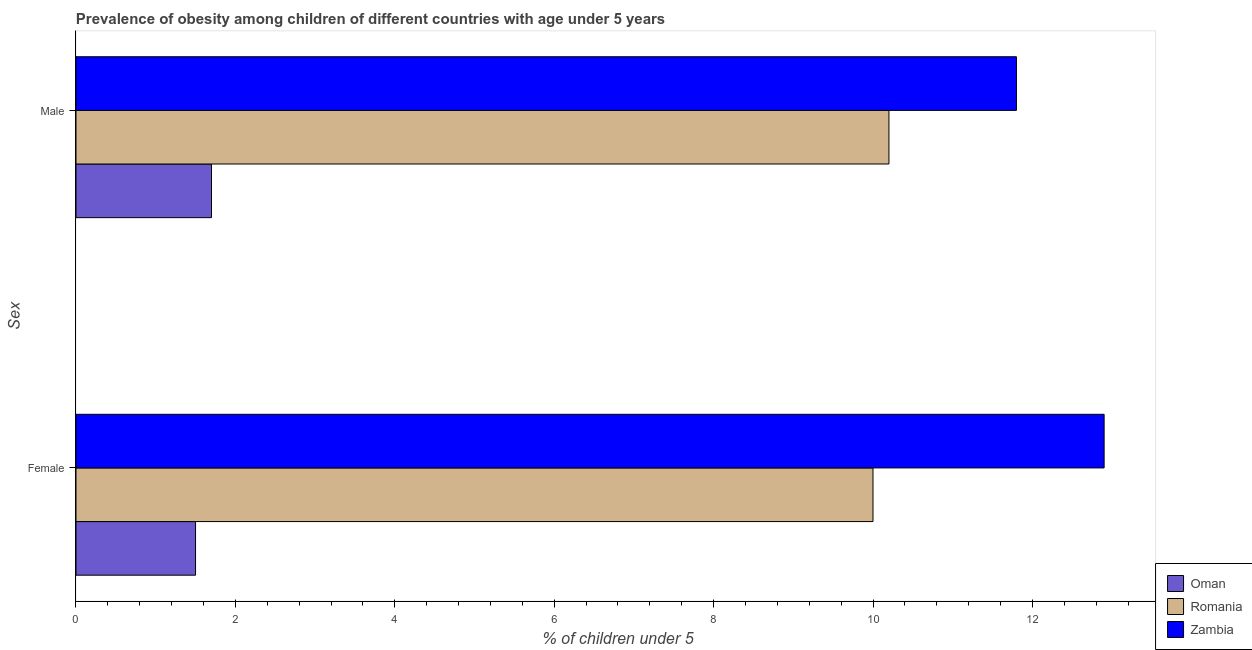How many different coloured bars are there?
Ensure brevity in your answer.  3. How many groups of bars are there?
Offer a very short reply. 2. Are the number of bars per tick equal to the number of legend labels?
Provide a short and direct response. Yes. Are the number of bars on each tick of the Y-axis equal?
Your answer should be very brief. Yes. How many bars are there on the 1st tick from the bottom?
Provide a short and direct response. 3. What is the percentage of obese female children in Romania?
Offer a terse response. 10. Across all countries, what is the maximum percentage of obese male children?
Keep it short and to the point. 11.8. Across all countries, what is the minimum percentage of obese female children?
Offer a terse response. 1.5. In which country was the percentage of obese male children maximum?
Ensure brevity in your answer.  Zambia. In which country was the percentage of obese male children minimum?
Your answer should be very brief. Oman. What is the total percentage of obese female children in the graph?
Offer a terse response. 24.4. What is the difference between the percentage of obese male children in Romania and that in Oman?
Your answer should be very brief. 8.5. What is the difference between the percentage of obese male children in Zambia and the percentage of obese female children in Oman?
Your response must be concise. 10.3. What is the average percentage of obese female children per country?
Make the answer very short. 8.13. What is the difference between the percentage of obese male children and percentage of obese female children in Zambia?
Provide a short and direct response. -1.1. In how many countries, is the percentage of obese female children greater than 10.4 %?
Your answer should be compact. 1. What is the ratio of the percentage of obese female children in Zambia to that in Oman?
Make the answer very short. 8.6. In how many countries, is the percentage of obese male children greater than the average percentage of obese male children taken over all countries?
Offer a very short reply. 2. What does the 3rd bar from the top in Female represents?
Your response must be concise. Oman. What does the 2nd bar from the bottom in Female represents?
Provide a succinct answer. Romania. Are the values on the major ticks of X-axis written in scientific E-notation?
Ensure brevity in your answer.  No. Where does the legend appear in the graph?
Your answer should be compact. Bottom right. What is the title of the graph?
Your answer should be compact. Prevalence of obesity among children of different countries with age under 5 years. Does "Suriname" appear as one of the legend labels in the graph?
Ensure brevity in your answer.  No. What is the label or title of the X-axis?
Offer a terse response.  % of children under 5. What is the label or title of the Y-axis?
Offer a very short reply. Sex. What is the  % of children under 5 in Oman in Female?
Your response must be concise. 1.5. What is the  % of children under 5 of Romania in Female?
Your answer should be very brief. 10. What is the  % of children under 5 in Zambia in Female?
Offer a terse response. 12.9. What is the  % of children under 5 in Oman in Male?
Provide a short and direct response. 1.7. What is the  % of children under 5 in Romania in Male?
Ensure brevity in your answer.  10.2. What is the  % of children under 5 of Zambia in Male?
Provide a short and direct response. 11.8. Across all Sex, what is the maximum  % of children under 5 of Oman?
Your answer should be very brief. 1.7. Across all Sex, what is the maximum  % of children under 5 in Romania?
Your answer should be very brief. 10.2. Across all Sex, what is the maximum  % of children under 5 of Zambia?
Ensure brevity in your answer.  12.9. Across all Sex, what is the minimum  % of children under 5 of Zambia?
Your answer should be very brief. 11.8. What is the total  % of children under 5 in Oman in the graph?
Your response must be concise. 3.2. What is the total  % of children under 5 of Romania in the graph?
Your answer should be very brief. 20.2. What is the total  % of children under 5 in Zambia in the graph?
Your answer should be very brief. 24.7. What is the difference between the  % of children under 5 in Zambia in Female and that in Male?
Provide a succinct answer. 1.1. What is the average  % of children under 5 in Oman per Sex?
Make the answer very short. 1.6. What is the average  % of children under 5 in Zambia per Sex?
Your answer should be compact. 12.35. What is the difference between the  % of children under 5 of Oman and  % of children under 5 of Romania in Female?
Your answer should be very brief. -8.5. What is the difference between the  % of children under 5 of Oman and  % of children under 5 of Zambia in Female?
Your response must be concise. -11.4. What is the difference between the  % of children under 5 of Oman and  % of children under 5 of Romania in Male?
Your answer should be very brief. -8.5. What is the difference between the  % of children under 5 in Oman and  % of children under 5 in Zambia in Male?
Your answer should be very brief. -10.1. What is the difference between the  % of children under 5 of Romania and  % of children under 5 of Zambia in Male?
Provide a succinct answer. -1.6. What is the ratio of the  % of children under 5 in Oman in Female to that in Male?
Make the answer very short. 0.88. What is the ratio of the  % of children under 5 in Romania in Female to that in Male?
Provide a short and direct response. 0.98. What is the ratio of the  % of children under 5 in Zambia in Female to that in Male?
Ensure brevity in your answer.  1.09. What is the difference between the highest and the second highest  % of children under 5 in Zambia?
Provide a short and direct response. 1.1. What is the difference between the highest and the lowest  % of children under 5 of Oman?
Give a very brief answer. 0.2. What is the difference between the highest and the lowest  % of children under 5 of Zambia?
Ensure brevity in your answer.  1.1. 